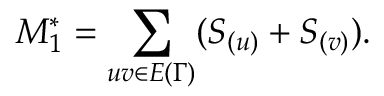<formula> <loc_0><loc_0><loc_500><loc_500>M _ { 1 } ^ { * } = \sum _ { u v \in E { ( \Gamma ) } } ( S _ { ( u ) } + S _ { ( v ) } ) .</formula> 